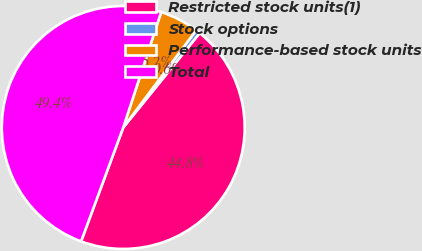Convert chart. <chart><loc_0><loc_0><loc_500><loc_500><pie_chart><fcel>Restricted stock units(1)<fcel>Stock options<fcel>Performance-based stock units<fcel>Total<nl><fcel>44.81%<fcel>0.59%<fcel>5.19%<fcel>49.41%<nl></chart> 